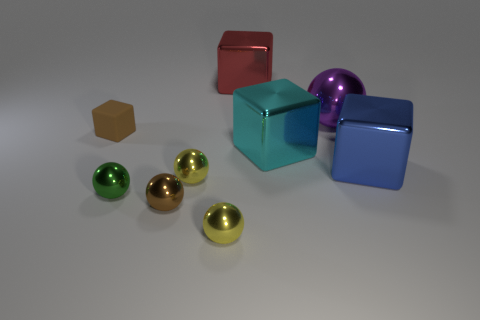Subtract all big blue cubes. How many cubes are left? 3 Subtract all yellow balls. How many balls are left? 3 Subtract all green cubes. How many yellow balls are left? 2 Subtract 1 spheres. How many spheres are left? 4 Subtract all blocks. How many objects are left? 5 Subtract all small blocks. Subtract all large brown spheres. How many objects are left? 8 Add 1 big blue cubes. How many big blue cubes are left? 2 Add 5 cyan shiny objects. How many cyan shiny objects exist? 6 Subtract 0 yellow cylinders. How many objects are left? 9 Subtract all green spheres. Subtract all purple cubes. How many spheres are left? 4 